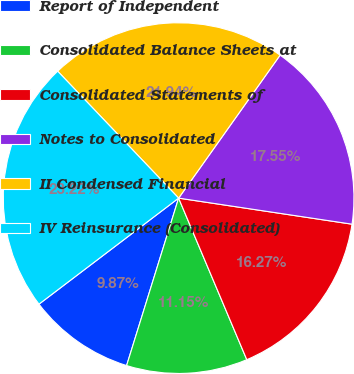Convert chart to OTSL. <chart><loc_0><loc_0><loc_500><loc_500><pie_chart><fcel>Report of Independent<fcel>Consolidated Balance Sheets at<fcel>Consolidated Statements of<fcel>Notes to Consolidated<fcel>II Condensed Financial<fcel>IV Reinsurance (Consolidated)<nl><fcel>9.87%<fcel>11.15%<fcel>16.27%<fcel>17.55%<fcel>21.94%<fcel>23.22%<nl></chart> 